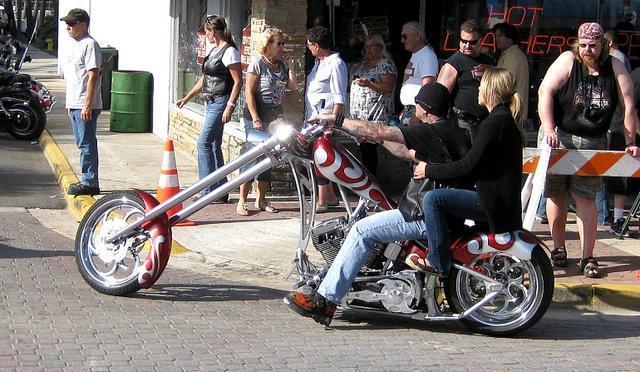How many people are on the motorcycle?
Give a very brief answer. 2. How many people are in the photo?
Give a very brief answer. 10. 